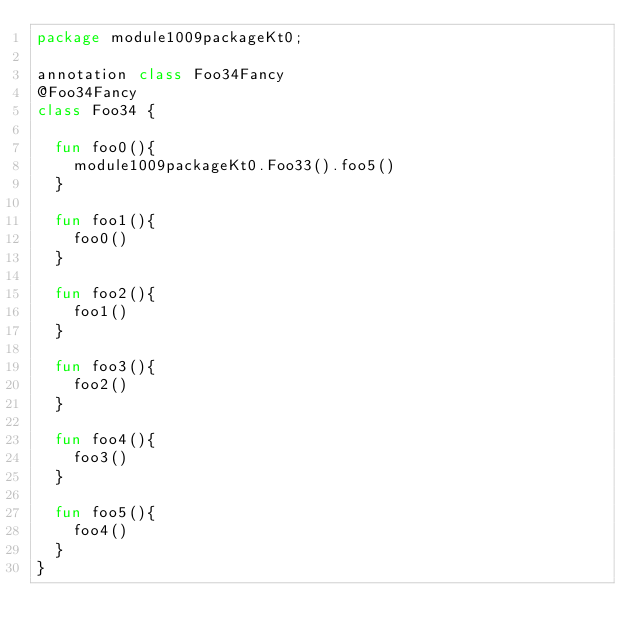<code> <loc_0><loc_0><loc_500><loc_500><_Kotlin_>package module1009packageKt0;

annotation class Foo34Fancy
@Foo34Fancy
class Foo34 {

  fun foo0(){
    module1009packageKt0.Foo33().foo5()
  }

  fun foo1(){
    foo0()
  }

  fun foo2(){
    foo1()
  }

  fun foo3(){
    foo2()
  }

  fun foo4(){
    foo3()
  }

  fun foo5(){
    foo4()
  }
}</code> 